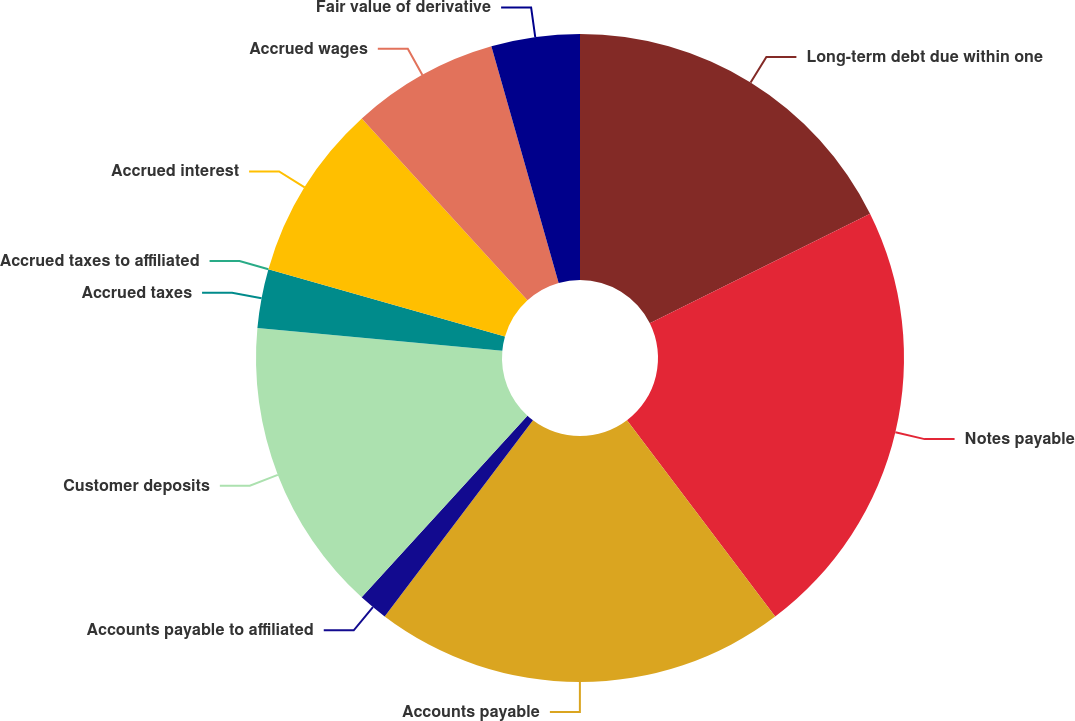Convert chart. <chart><loc_0><loc_0><loc_500><loc_500><pie_chart><fcel>Long-term debt due within one<fcel>Notes payable<fcel>Accounts payable<fcel>Accounts payable to affiliated<fcel>Customer deposits<fcel>Accrued taxes<fcel>Accrued taxes to affiliated<fcel>Accrued interest<fcel>Accrued wages<fcel>Fair value of derivative<nl><fcel>17.65%<fcel>22.06%<fcel>20.59%<fcel>1.47%<fcel>14.71%<fcel>2.94%<fcel>0.0%<fcel>8.82%<fcel>7.35%<fcel>4.41%<nl></chart> 